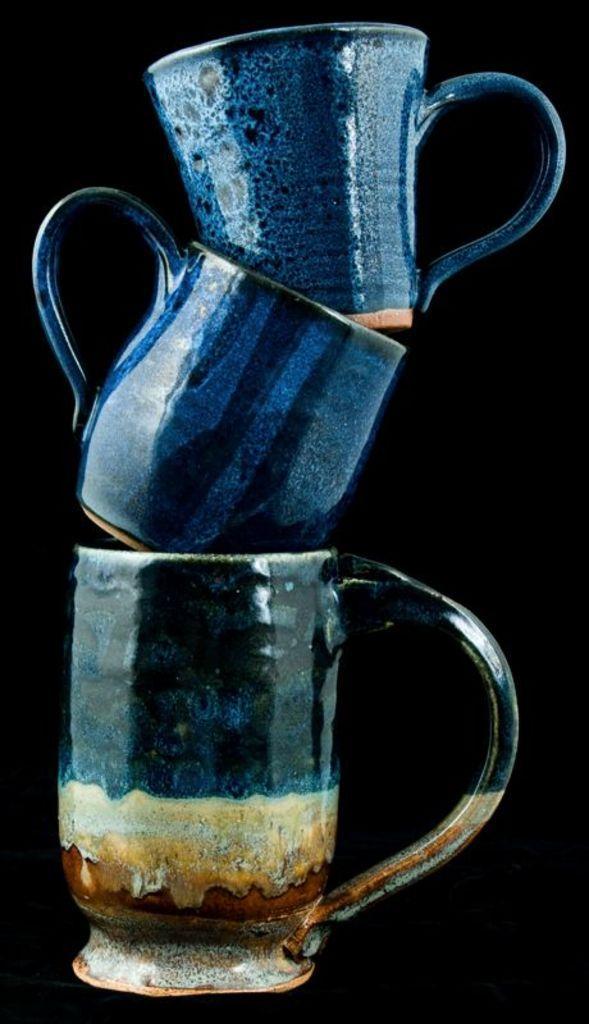Can you describe this image briefly? There is a cup. On that there is a cup. On that cup there is another cup. In the back it is black. 